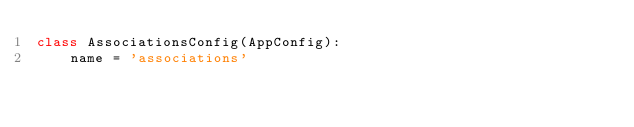<code> <loc_0><loc_0><loc_500><loc_500><_Python_>class AssociationsConfig(AppConfig):
    name = 'associations'
</code> 